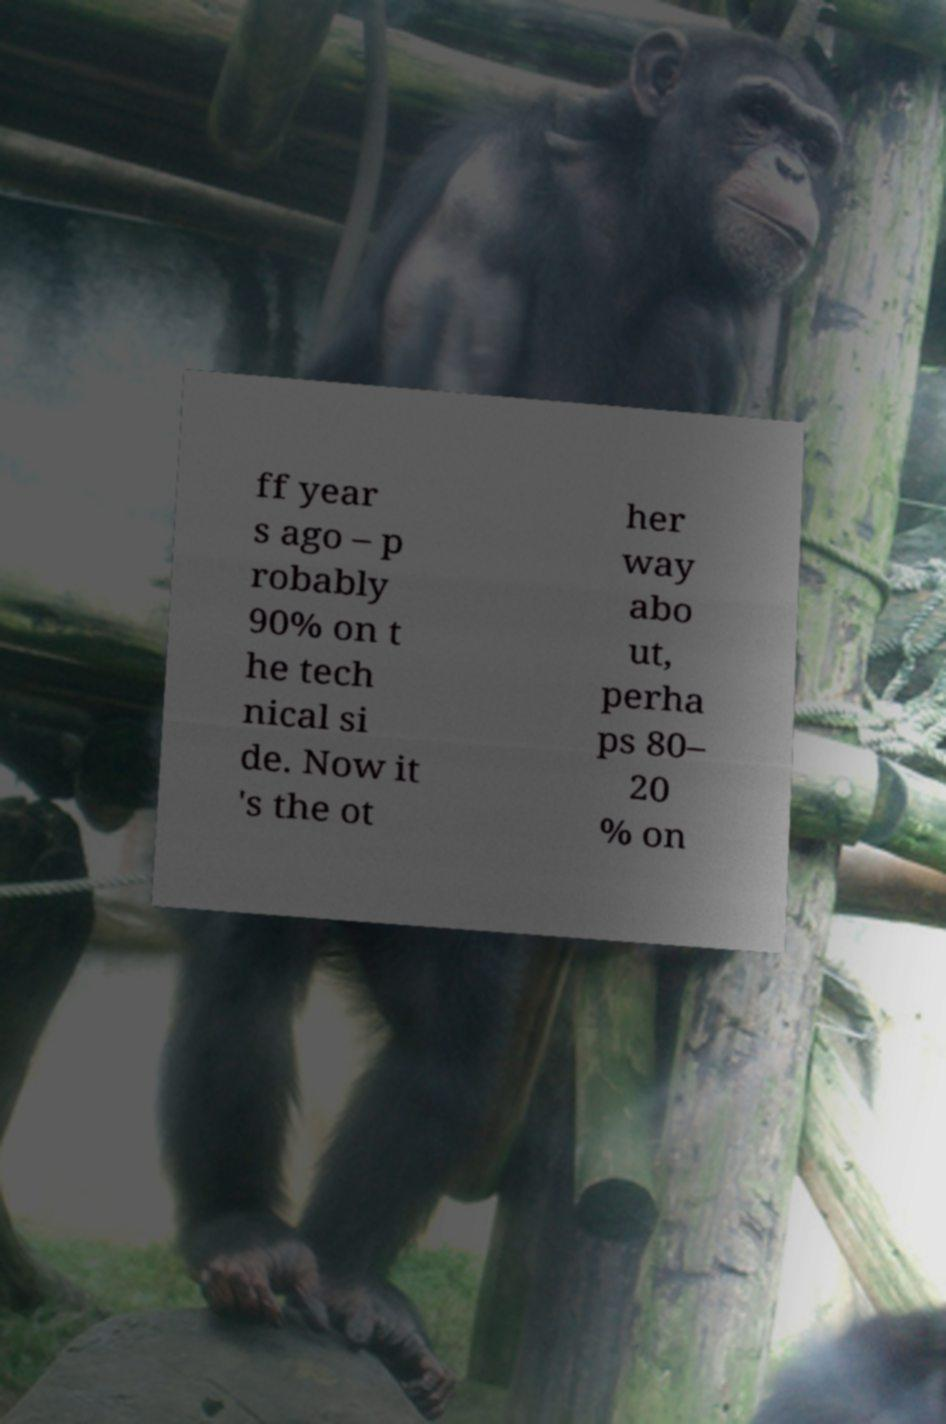Can you read and provide the text displayed in the image?This photo seems to have some interesting text. Can you extract and type it out for me? ff year s ago – p robably 90% on t he tech nical si de. Now it 's the ot her way abo ut, perha ps 80– 20 % on 